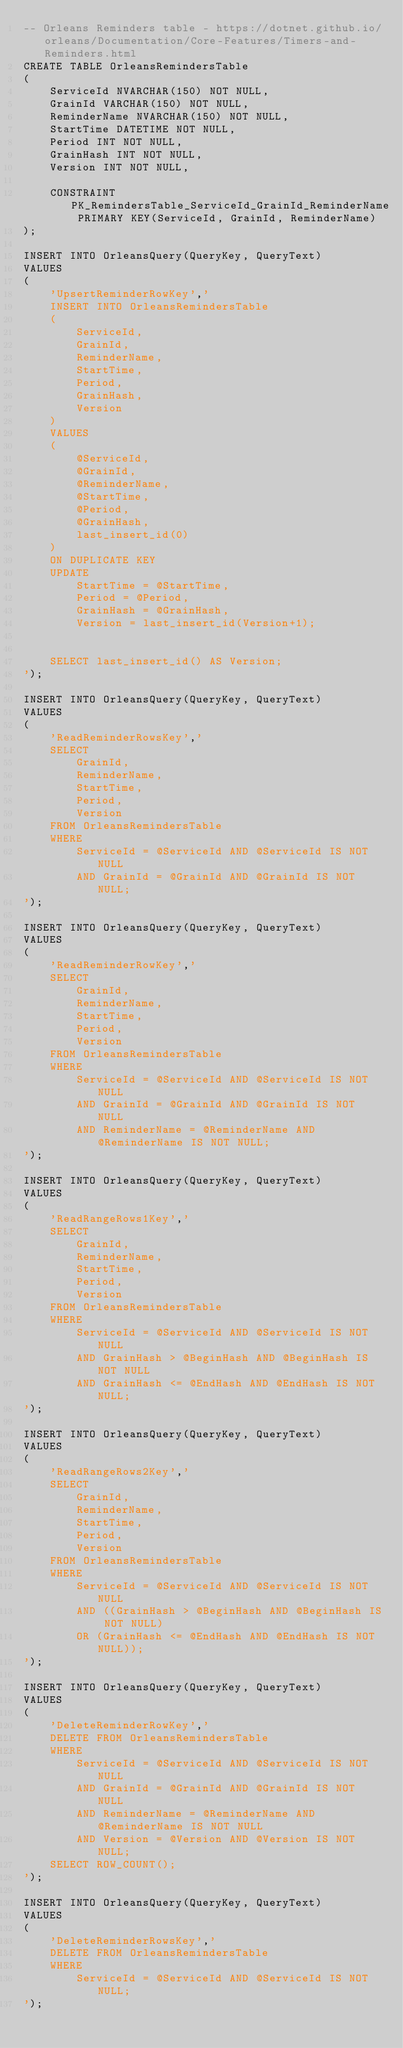Convert code to text. <code><loc_0><loc_0><loc_500><loc_500><_SQL_>-- Orleans Reminders table - https://dotnet.github.io/orleans/Documentation/Core-Features/Timers-and-Reminders.html
CREATE TABLE OrleansRemindersTable
(
    ServiceId NVARCHAR(150) NOT NULL,
    GrainId VARCHAR(150) NOT NULL,
    ReminderName NVARCHAR(150) NOT NULL,
    StartTime DATETIME NOT NULL,
    Period INT NOT NULL,
    GrainHash INT NOT NULL,
    Version INT NOT NULL,

    CONSTRAINT PK_RemindersTable_ServiceId_GrainId_ReminderName PRIMARY KEY(ServiceId, GrainId, ReminderName)
);

INSERT INTO OrleansQuery(QueryKey, QueryText)
VALUES
(
    'UpsertReminderRowKey','
    INSERT INTO OrleansRemindersTable
    (
        ServiceId,
        GrainId,
        ReminderName,
        StartTime,
        Period,
        GrainHash,
        Version
    )
    VALUES
    (
        @ServiceId,
        @GrainId,
        @ReminderName,
        @StartTime,
        @Period,
        @GrainHash,
        last_insert_id(0)
    )
    ON DUPLICATE KEY
    UPDATE
        StartTime = @StartTime,
        Period = @Period,
        GrainHash = @GrainHash,
        Version = last_insert_id(Version+1);


    SELECT last_insert_id() AS Version;
');

INSERT INTO OrleansQuery(QueryKey, QueryText)
VALUES
(
    'ReadReminderRowsKey','
    SELECT
        GrainId,
        ReminderName,
        StartTime,
        Period,
        Version
    FROM OrleansRemindersTable
    WHERE
        ServiceId = @ServiceId AND @ServiceId IS NOT NULL
        AND GrainId = @GrainId AND @GrainId IS NOT NULL;
');

INSERT INTO OrleansQuery(QueryKey, QueryText)
VALUES
(
    'ReadReminderRowKey','
    SELECT
        GrainId,
        ReminderName,
        StartTime,
        Period,
        Version
    FROM OrleansRemindersTable
    WHERE
        ServiceId = @ServiceId AND @ServiceId IS NOT NULL
        AND GrainId = @GrainId AND @GrainId IS NOT NULL
        AND ReminderName = @ReminderName AND @ReminderName IS NOT NULL;
');

INSERT INTO OrleansQuery(QueryKey, QueryText)
VALUES
(
    'ReadRangeRows1Key','
    SELECT
        GrainId,
        ReminderName,
        StartTime,
        Period,
        Version
    FROM OrleansRemindersTable
    WHERE
        ServiceId = @ServiceId AND @ServiceId IS NOT NULL
        AND GrainHash > @BeginHash AND @BeginHash IS NOT NULL
        AND GrainHash <= @EndHash AND @EndHash IS NOT NULL;
');

INSERT INTO OrleansQuery(QueryKey, QueryText)
VALUES
(
    'ReadRangeRows2Key','
    SELECT
        GrainId,
        ReminderName,
        StartTime,
        Period,
        Version
    FROM OrleansRemindersTable
    WHERE
        ServiceId = @ServiceId AND @ServiceId IS NOT NULL
        AND ((GrainHash > @BeginHash AND @BeginHash IS NOT NULL)
        OR (GrainHash <= @EndHash AND @EndHash IS NOT NULL));
');

INSERT INTO OrleansQuery(QueryKey, QueryText)
VALUES
(
    'DeleteReminderRowKey','
    DELETE FROM OrleansRemindersTable
    WHERE
        ServiceId = @ServiceId AND @ServiceId IS NOT NULL
        AND GrainId = @GrainId AND @GrainId IS NOT NULL
        AND ReminderName = @ReminderName AND @ReminderName IS NOT NULL
        AND Version = @Version AND @Version IS NOT NULL;
    SELECT ROW_COUNT();
');

INSERT INTO OrleansQuery(QueryKey, QueryText)
VALUES
(
    'DeleteReminderRowsKey','
    DELETE FROM OrleansRemindersTable
    WHERE
        ServiceId = @ServiceId AND @ServiceId IS NOT NULL;
');
</code> 